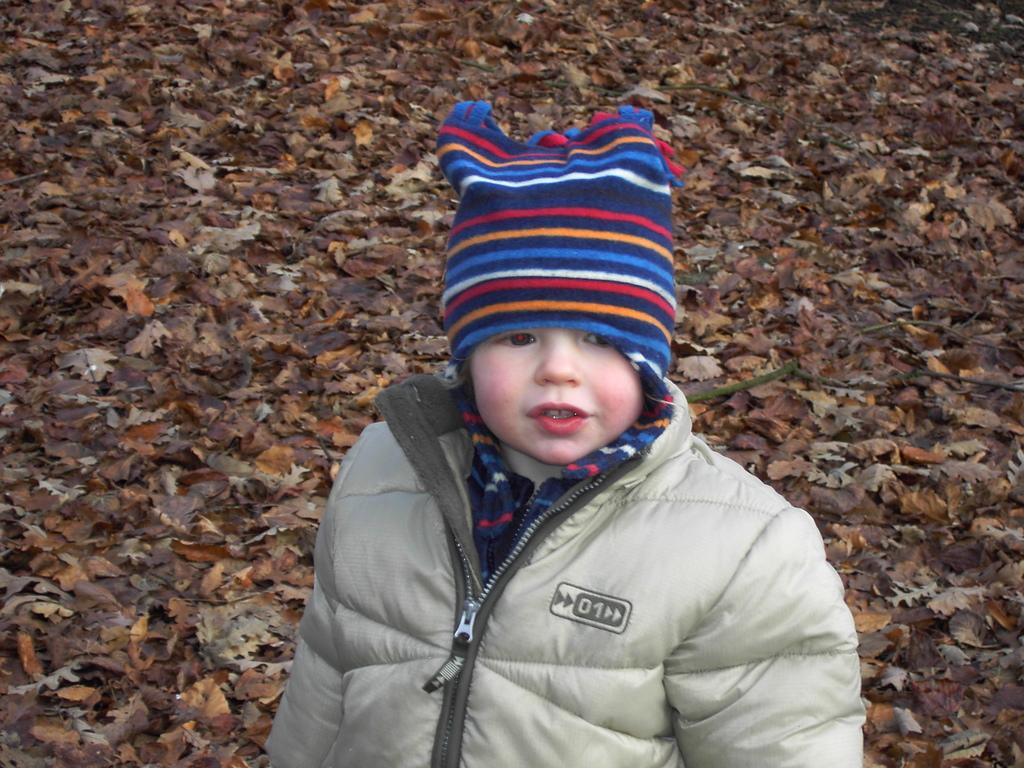Who is the main subject in the image? There is a boy in the image. What is the boy wearing in the image? The boy is wearing a jacket and a hat. What can be seen in the background of the image? There are dry leaves in the background of the image. How many sisters does the boy have in the image? There is no information about the boy's sisters in the image. What type of berry can be seen growing on the hat in the image? There are no berries present on the hat in the image. 